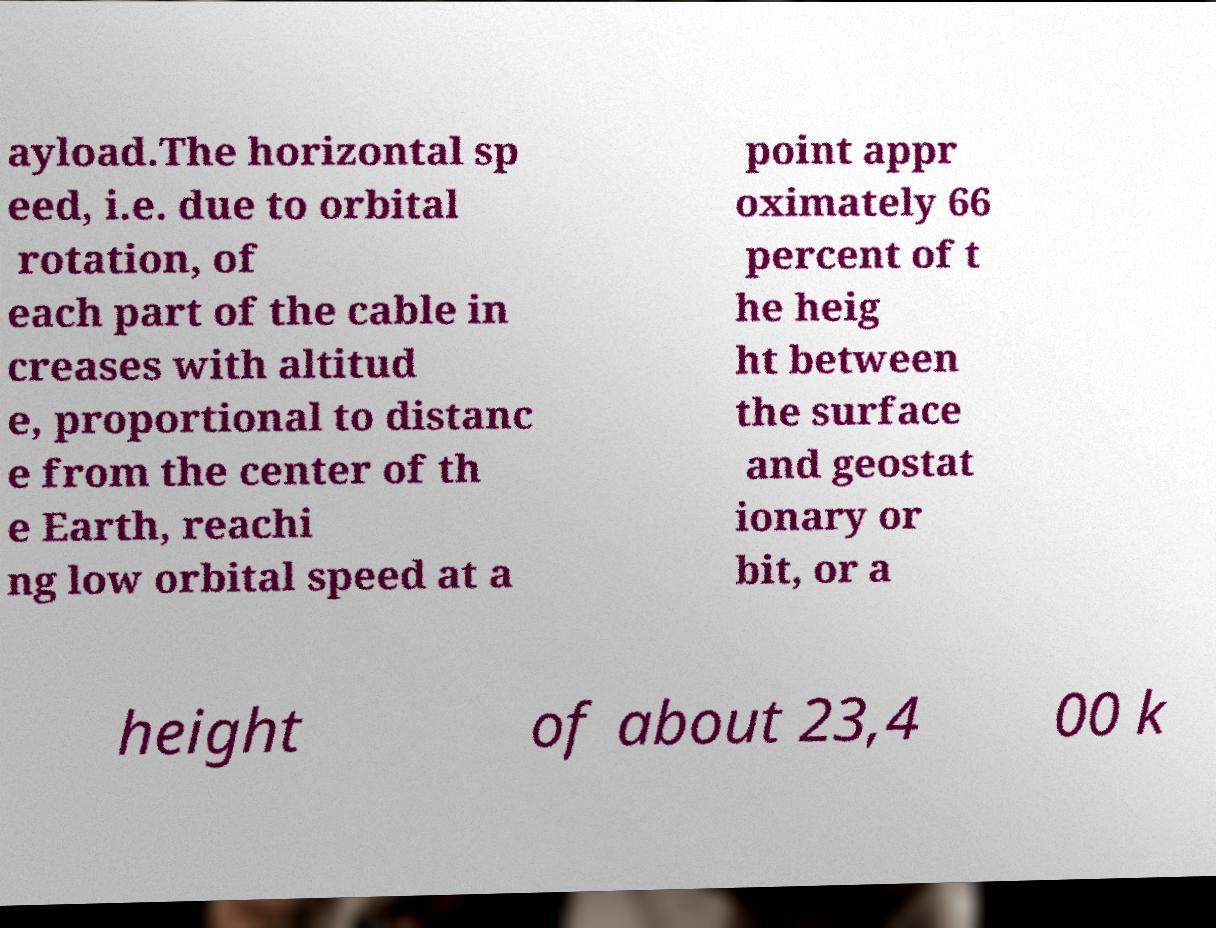There's text embedded in this image that I need extracted. Can you transcribe it verbatim? ayload.The horizontal sp eed, i.e. due to orbital rotation, of each part of the cable in creases with altitud e, proportional to distanc e from the center of th e Earth, reachi ng low orbital speed at a point appr oximately 66 percent of t he heig ht between the surface and geostat ionary or bit, or a height of about 23,4 00 k 